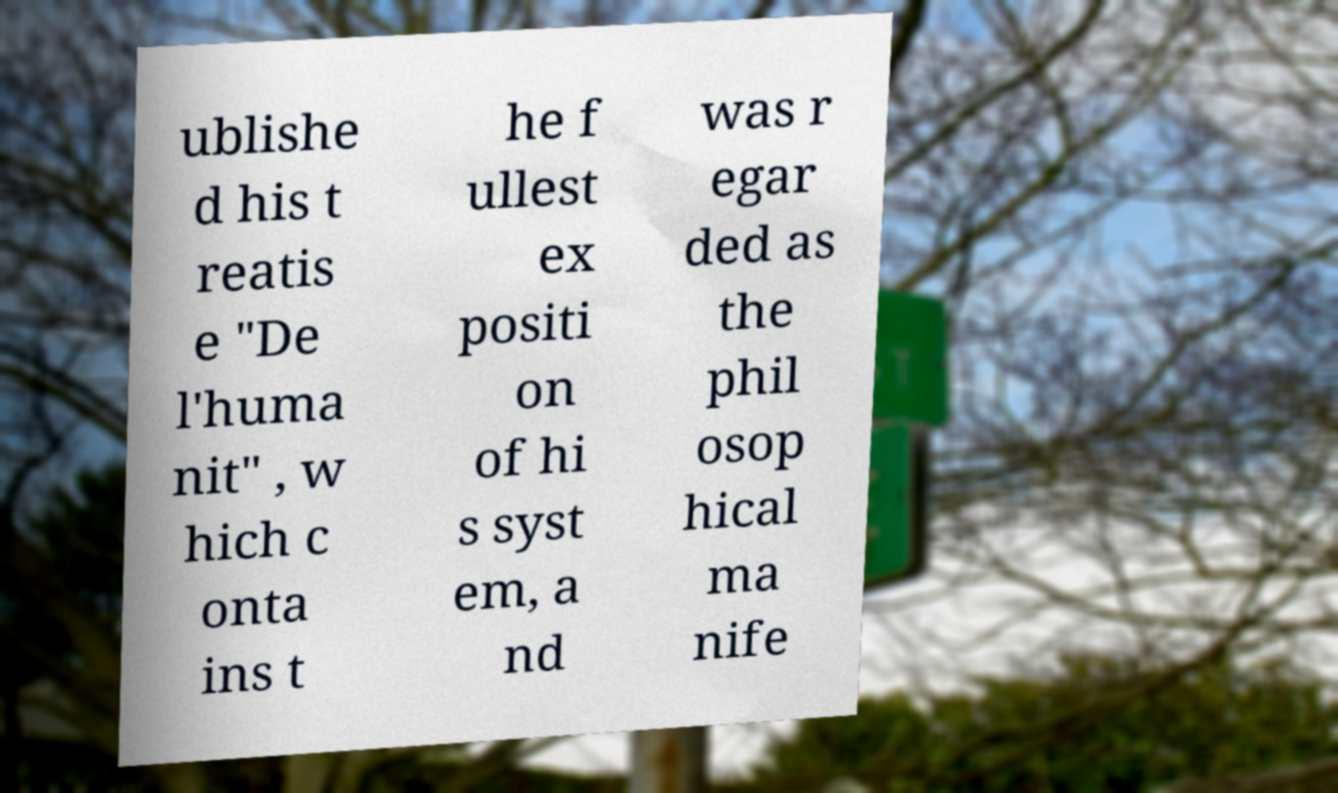Can you read and provide the text displayed in the image?This photo seems to have some interesting text. Can you extract and type it out for me? ublishe d his t reatis e "De l'huma nit" , w hich c onta ins t he f ullest ex positi on of hi s syst em, a nd was r egar ded as the phil osop hical ma nife 